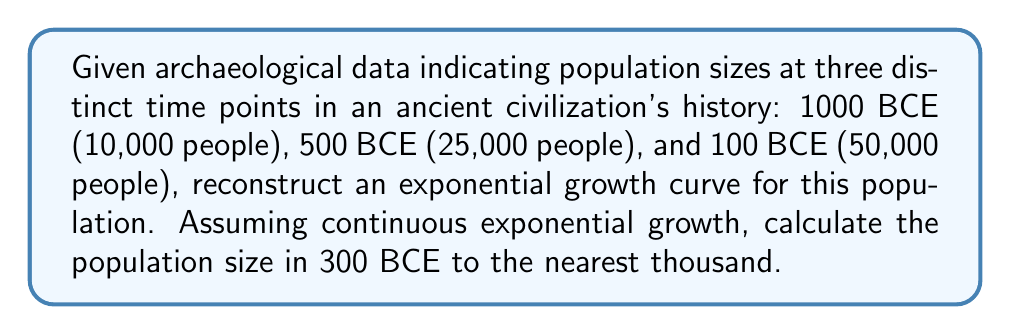What is the answer to this math problem? To reconstruct the population growth curve and estimate the population at 300 BCE, we'll follow these steps:

1. Assume the population growth follows the exponential model:
   $P(t) = P_0 e^{rt}$
   where $P(t)$ is the population at time $t$, $P_0$ is the initial population, $r$ is the growth rate, and $t$ is time.

2. Use the given data points to determine the growth rate $r$. We can use any two points for this calculation. Let's use 1000 BCE and 100 BCE:

   $50000 = 10000 e^{900r}$

3. Solve for $r$:
   $$\begin{align}
   5 &= e^{900r} \\
   \ln(5) &= 900r \\
   r &= \frac{\ln(5)}{900} \approx 0.001784
   \end{align}$$

4. Now that we have $r$, we can use the exponential growth formula to estimate the population at 300 BCE. Set $t = 700$ (time elapsed from 1000 BCE to 300 BCE):

   $P(700) = 10000 e^{0.001784 * 700}$

5. Calculate:
   $P(700) \approx 10000 * 3.4728 \approx 34,728$

6. Rounding to the nearest thousand:
   Population at 300 BCE ≈ 35,000
Answer: 35,000 